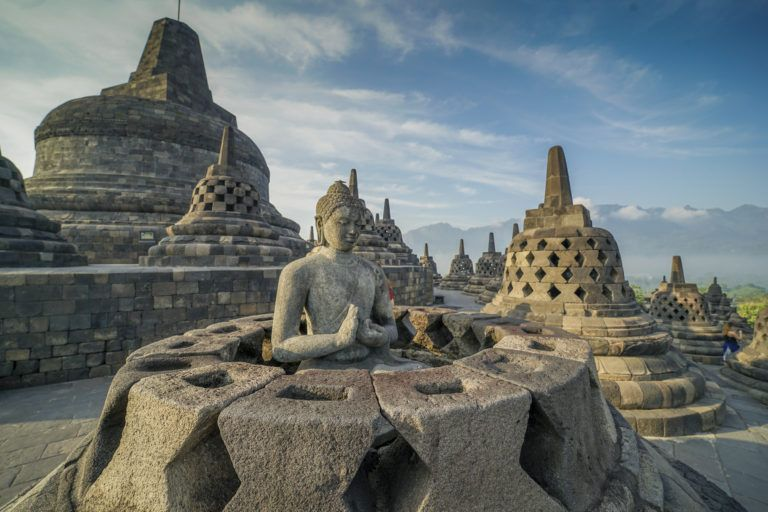If this temple could speak, what stories might it tell? If Borobodur Temple could speak, it would tell tales of kings and monks, of fervent prayers and grand processions. It would recount the bustling activity during its construction, with artisans dedicating their lives to carving intricate designs into the stones. It would share the wisdom contained in its reliefs, illustrating the Buddha’s teachings and the principles of karma. The temple might tell of the days it stood abandoned, shrouded in mystery and jungle vines, until its rediscovery awakened it from centuries of slumber. It would speak of the millions of pilgrims and visitors who have walked its steps, each bringing their own hopes, dreams, and reverence, adding to the temple’s rich tapestry of history. 